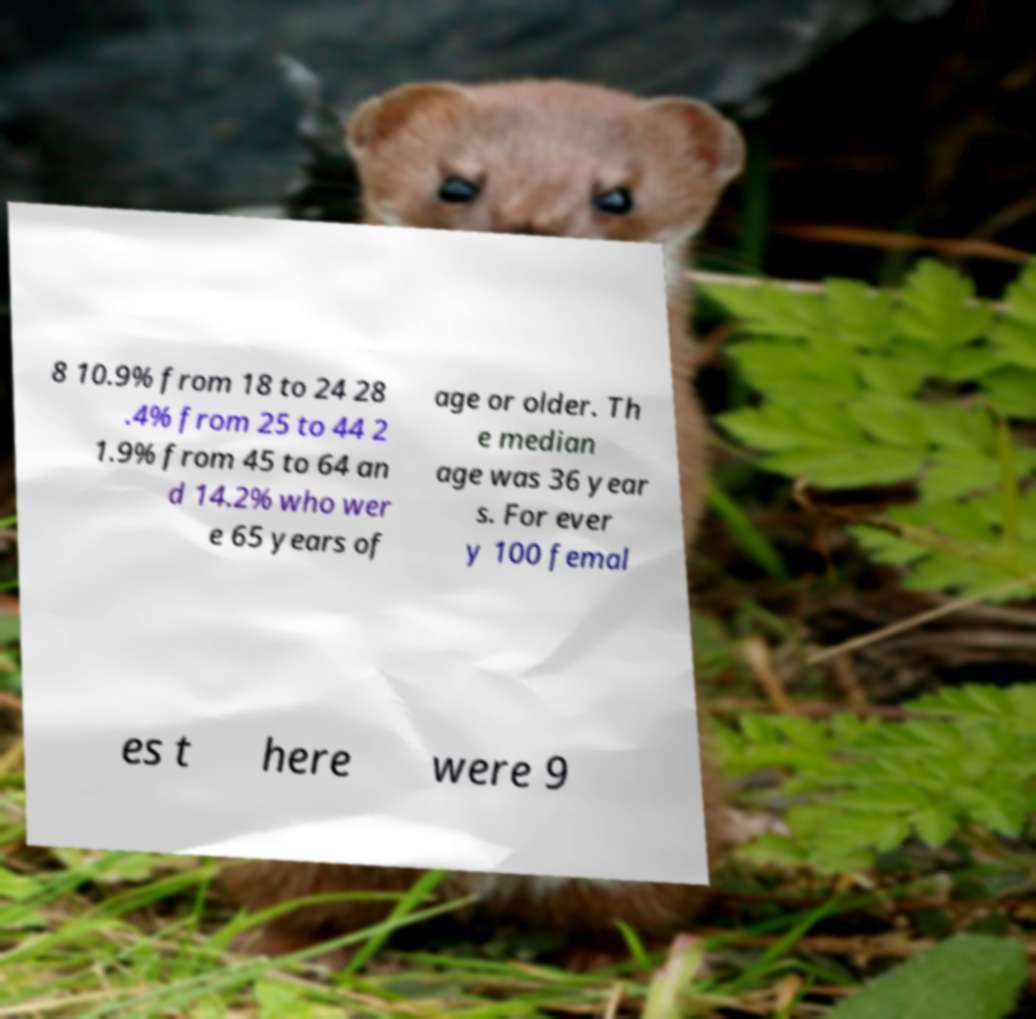What messages or text are displayed in this image? I need them in a readable, typed format. 8 10.9% from 18 to 24 28 .4% from 25 to 44 2 1.9% from 45 to 64 an d 14.2% who wer e 65 years of age or older. Th e median age was 36 year s. For ever y 100 femal es t here were 9 